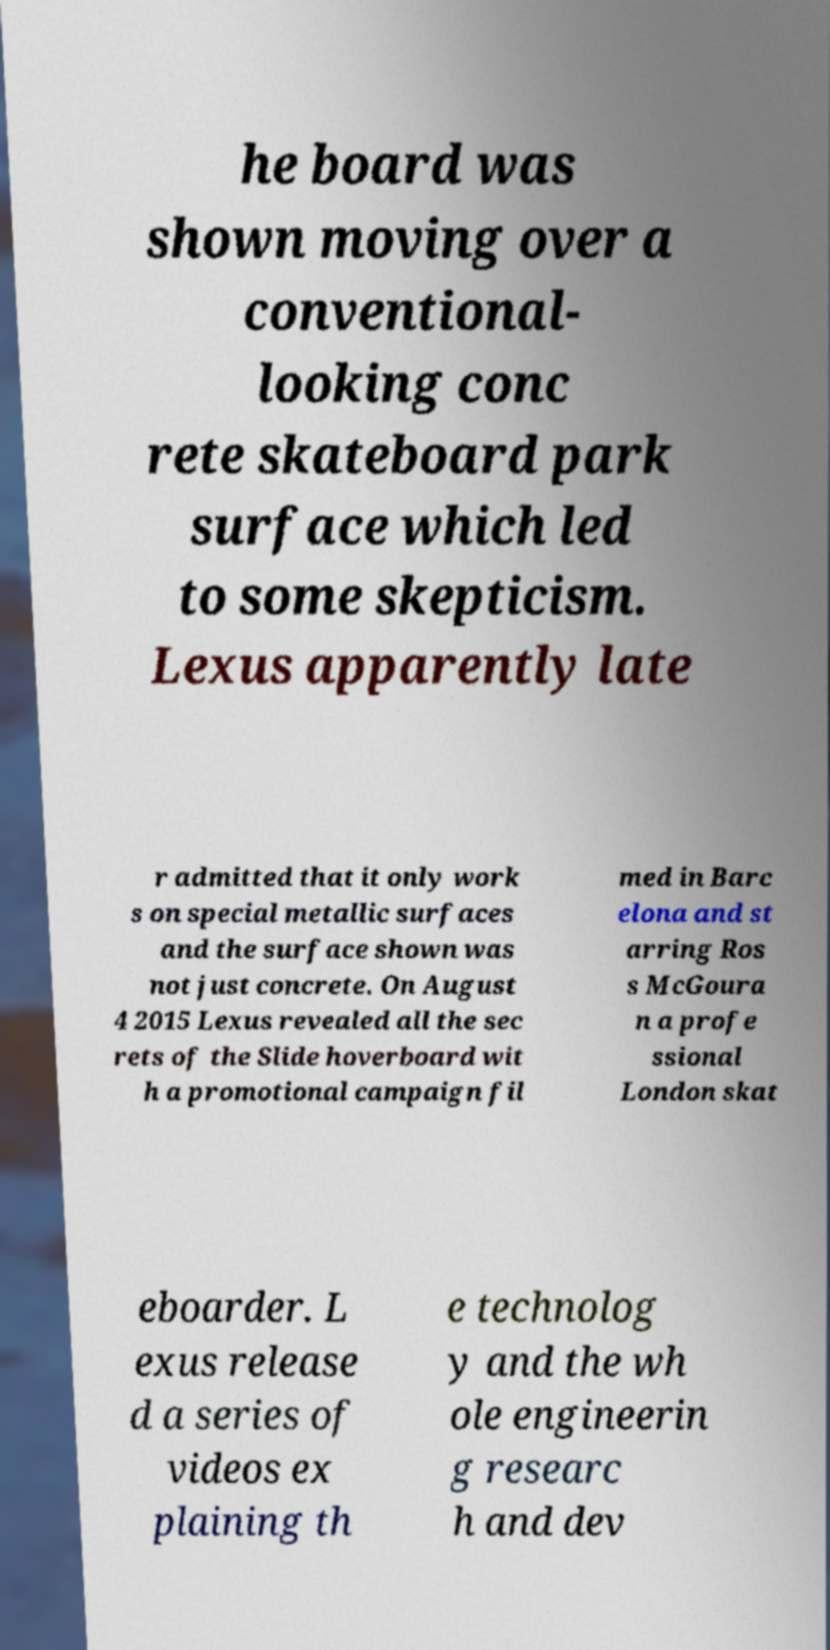Could you assist in decoding the text presented in this image and type it out clearly? he board was shown moving over a conventional- looking conc rete skateboard park surface which led to some skepticism. Lexus apparently late r admitted that it only work s on special metallic surfaces and the surface shown was not just concrete. On August 4 2015 Lexus revealed all the sec rets of the Slide hoverboard wit h a promotional campaign fil med in Barc elona and st arring Ros s McGoura n a profe ssional London skat eboarder. L exus release d a series of videos ex plaining th e technolog y and the wh ole engineerin g researc h and dev 